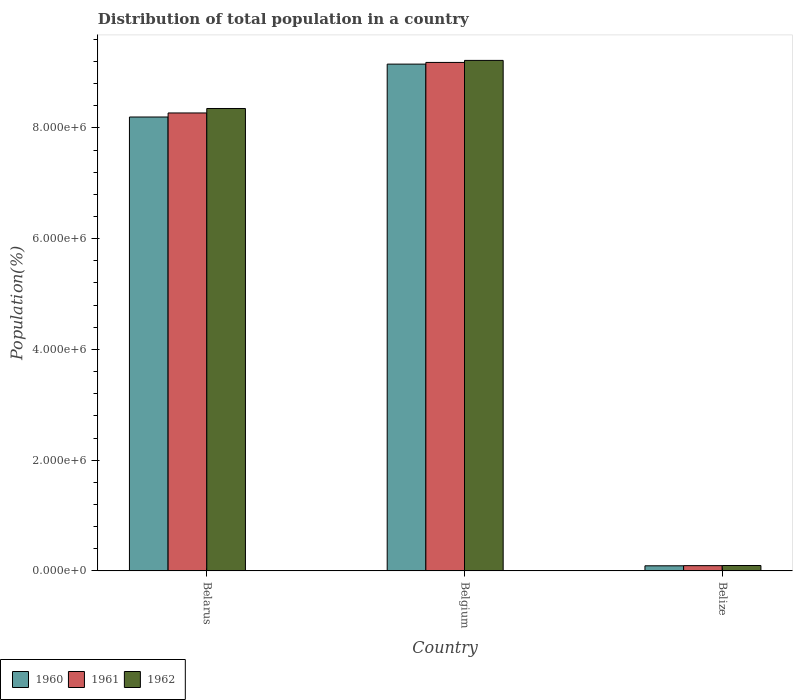How many different coloured bars are there?
Make the answer very short. 3. How many groups of bars are there?
Offer a terse response. 3. Are the number of bars per tick equal to the number of legend labels?
Your response must be concise. Yes. Are the number of bars on each tick of the X-axis equal?
Your answer should be compact. Yes. How many bars are there on the 2nd tick from the left?
Offer a terse response. 3. How many bars are there on the 2nd tick from the right?
Give a very brief answer. 3. What is the label of the 3rd group of bars from the left?
Provide a short and direct response. Belize. In how many cases, is the number of bars for a given country not equal to the number of legend labels?
Provide a succinct answer. 0. What is the population of in 1960 in Belize?
Offer a very short reply. 9.21e+04. Across all countries, what is the maximum population of in 1960?
Offer a terse response. 9.15e+06. Across all countries, what is the minimum population of in 1962?
Make the answer very short. 9.74e+04. In which country was the population of in 1962 maximum?
Provide a succinct answer. Belgium. In which country was the population of in 1960 minimum?
Ensure brevity in your answer.  Belize. What is the total population of in 1961 in the graph?
Provide a short and direct response. 1.75e+07. What is the difference between the population of in 1961 in Belgium and that in Belize?
Provide a short and direct response. 9.09e+06. What is the difference between the population of in 1962 in Belarus and the population of in 1961 in Belgium?
Provide a succinct answer. -8.32e+05. What is the average population of in 1961 per country?
Provide a short and direct response. 5.85e+06. What is the difference between the population of of/in 1960 and population of of/in 1962 in Belize?
Your answer should be compact. -5321. In how many countries, is the population of in 1962 greater than 2800000 %?
Give a very brief answer. 2. What is the ratio of the population of in 1960 in Belarus to that in Belgium?
Ensure brevity in your answer.  0.9. Is the population of in 1960 in Belarus less than that in Belgium?
Ensure brevity in your answer.  Yes. What is the difference between the highest and the second highest population of in 1961?
Ensure brevity in your answer.  -9.13e+05. What is the difference between the highest and the lowest population of in 1961?
Ensure brevity in your answer.  9.09e+06. What does the 3rd bar from the left in Belgium represents?
Keep it short and to the point. 1962. Is it the case that in every country, the sum of the population of in 1960 and population of in 1961 is greater than the population of in 1962?
Your response must be concise. Yes. Are the values on the major ticks of Y-axis written in scientific E-notation?
Ensure brevity in your answer.  Yes. Does the graph contain any zero values?
Your answer should be compact. No. Does the graph contain grids?
Give a very brief answer. No. Where does the legend appear in the graph?
Make the answer very short. Bottom left. How many legend labels are there?
Keep it short and to the point. 3. What is the title of the graph?
Offer a very short reply. Distribution of total population in a country. What is the label or title of the Y-axis?
Your answer should be compact. Population(%). What is the Population(%) of 1960 in Belarus?
Your response must be concise. 8.20e+06. What is the Population(%) of 1961 in Belarus?
Offer a terse response. 8.27e+06. What is the Population(%) in 1962 in Belarus?
Give a very brief answer. 8.35e+06. What is the Population(%) of 1960 in Belgium?
Make the answer very short. 9.15e+06. What is the Population(%) of 1961 in Belgium?
Offer a very short reply. 9.18e+06. What is the Population(%) of 1962 in Belgium?
Offer a terse response. 9.22e+06. What is the Population(%) of 1960 in Belize?
Ensure brevity in your answer.  9.21e+04. What is the Population(%) in 1961 in Belize?
Make the answer very short. 9.47e+04. What is the Population(%) in 1962 in Belize?
Your answer should be very brief. 9.74e+04. Across all countries, what is the maximum Population(%) of 1960?
Your answer should be compact. 9.15e+06. Across all countries, what is the maximum Population(%) in 1961?
Keep it short and to the point. 9.18e+06. Across all countries, what is the maximum Population(%) of 1962?
Make the answer very short. 9.22e+06. Across all countries, what is the minimum Population(%) of 1960?
Provide a succinct answer. 9.21e+04. Across all countries, what is the minimum Population(%) in 1961?
Offer a terse response. 9.47e+04. Across all countries, what is the minimum Population(%) of 1962?
Your answer should be very brief. 9.74e+04. What is the total Population(%) in 1960 in the graph?
Your answer should be compact. 1.74e+07. What is the total Population(%) in 1961 in the graph?
Give a very brief answer. 1.75e+07. What is the total Population(%) in 1962 in the graph?
Keep it short and to the point. 1.77e+07. What is the difference between the Population(%) in 1960 in Belarus and that in Belgium?
Ensure brevity in your answer.  -9.55e+05. What is the difference between the Population(%) of 1961 in Belarus and that in Belgium?
Ensure brevity in your answer.  -9.13e+05. What is the difference between the Population(%) of 1962 in Belarus and that in Belgium?
Your response must be concise. -8.69e+05. What is the difference between the Population(%) of 1960 in Belarus and that in Belize?
Give a very brief answer. 8.11e+06. What is the difference between the Population(%) in 1961 in Belarus and that in Belize?
Offer a very short reply. 8.18e+06. What is the difference between the Population(%) in 1962 in Belarus and that in Belize?
Your answer should be compact. 8.25e+06. What is the difference between the Population(%) of 1960 in Belgium and that in Belize?
Your answer should be very brief. 9.06e+06. What is the difference between the Population(%) of 1961 in Belgium and that in Belize?
Make the answer very short. 9.09e+06. What is the difference between the Population(%) of 1962 in Belgium and that in Belize?
Offer a terse response. 9.12e+06. What is the difference between the Population(%) in 1960 in Belarus and the Population(%) in 1961 in Belgium?
Your answer should be very brief. -9.86e+05. What is the difference between the Population(%) of 1960 in Belarus and the Population(%) of 1962 in Belgium?
Offer a very short reply. -1.02e+06. What is the difference between the Population(%) in 1961 in Belarus and the Population(%) in 1962 in Belgium?
Your answer should be compact. -9.49e+05. What is the difference between the Population(%) in 1960 in Belarus and the Population(%) in 1961 in Belize?
Your response must be concise. 8.10e+06. What is the difference between the Population(%) in 1960 in Belarus and the Population(%) in 1962 in Belize?
Your response must be concise. 8.10e+06. What is the difference between the Population(%) of 1961 in Belarus and the Population(%) of 1962 in Belize?
Provide a succinct answer. 8.17e+06. What is the difference between the Population(%) of 1960 in Belgium and the Population(%) of 1961 in Belize?
Offer a very short reply. 9.06e+06. What is the difference between the Population(%) in 1960 in Belgium and the Population(%) in 1962 in Belize?
Your answer should be compact. 9.06e+06. What is the difference between the Population(%) in 1961 in Belgium and the Population(%) in 1962 in Belize?
Give a very brief answer. 9.09e+06. What is the average Population(%) in 1960 per country?
Provide a succinct answer. 5.81e+06. What is the average Population(%) of 1961 per country?
Keep it short and to the point. 5.85e+06. What is the average Population(%) in 1962 per country?
Keep it short and to the point. 5.89e+06. What is the difference between the Population(%) in 1960 and Population(%) in 1961 in Belarus?
Offer a very short reply. -7.32e+04. What is the difference between the Population(%) of 1960 and Population(%) of 1962 in Belarus?
Ensure brevity in your answer.  -1.54e+05. What is the difference between the Population(%) in 1961 and Population(%) in 1962 in Belarus?
Provide a succinct answer. -8.07e+04. What is the difference between the Population(%) in 1960 and Population(%) in 1961 in Belgium?
Give a very brief answer. -3.05e+04. What is the difference between the Population(%) of 1960 and Population(%) of 1962 in Belgium?
Keep it short and to the point. -6.71e+04. What is the difference between the Population(%) of 1961 and Population(%) of 1962 in Belgium?
Offer a very short reply. -3.66e+04. What is the difference between the Population(%) of 1960 and Population(%) of 1961 in Belize?
Provide a succinct answer. -2633. What is the difference between the Population(%) of 1960 and Population(%) of 1962 in Belize?
Your response must be concise. -5321. What is the difference between the Population(%) in 1961 and Population(%) in 1962 in Belize?
Offer a very short reply. -2688. What is the ratio of the Population(%) in 1960 in Belarus to that in Belgium?
Offer a very short reply. 0.9. What is the ratio of the Population(%) of 1961 in Belarus to that in Belgium?
Provide a succinct answer. 0.9. What is the ratio of the Population(%) of 1962 in Belarus to that in Belgium?
Keep it short and to the point. 0.91. What is the ratio of the Population(%) of 1960 in Belarus to that in Belize?
Offer a terse response. 89.04. What is the ratio of the Population(%) in 1961 in Belarus to that in Belize?
Your answer should be very brief. 87.34. What is the ratio of the Population(%) of 1962 in Belarus to that in Belize?
Ensure brevity in your answer.  85.76. What is the ratio of the Population(%) of 1960 in Belgium to that in Belize?
Your answer should be very brief. 99.42. What is the ratio of the Population(%) of 1961 in Belgium to that in Belize?
Offer a very short reply. 96.98. What is the ratio of the Population(%) of 1962 in Belgium to that in Belize?
Offer a terse response. 94.68. What is the difference between the highest and the second highest Population(%) in 1960?
Ensure brevity in your answer.  9.55e+05. What is the difference between the highest and the second highest Population(%) of 1961?
Keep it short and to the point. 9.13e+05. What is the difference between the highest and the second highest Population(%) of 1962?
Provide a succinct answer. 8.69e+05. What is the difference between the highest and the lowest Population(%) in 1960?
Make the answer very short. 9.06e+06. What is the difference between the highest and the lowest Population(%) of 1961?
Keep it short and to the point. 9.09e+06. What is the difference between the highest and the lowest Population(%) in 1962?
Ensure brevity in your answer.  9.12e+06. 